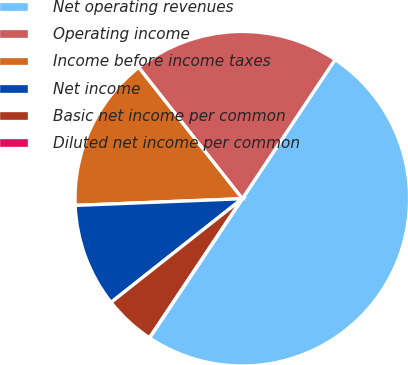Convert chart to OTSL. <chart><loc_0><loc_0><loc_500><loc_500><pie_chart><fcel>Net operating revenues<fcel>Operating income<fcel>Income before income taxes<fcel>Net income<fcel>Basic net income per common<fcel>Diluted net income per common<nl><fcel>50.0%<fcel>20.0%<fcel>15.0%<fcel>10.0%<fcel>5.0%<fcel>0.0%<nl></chart> 